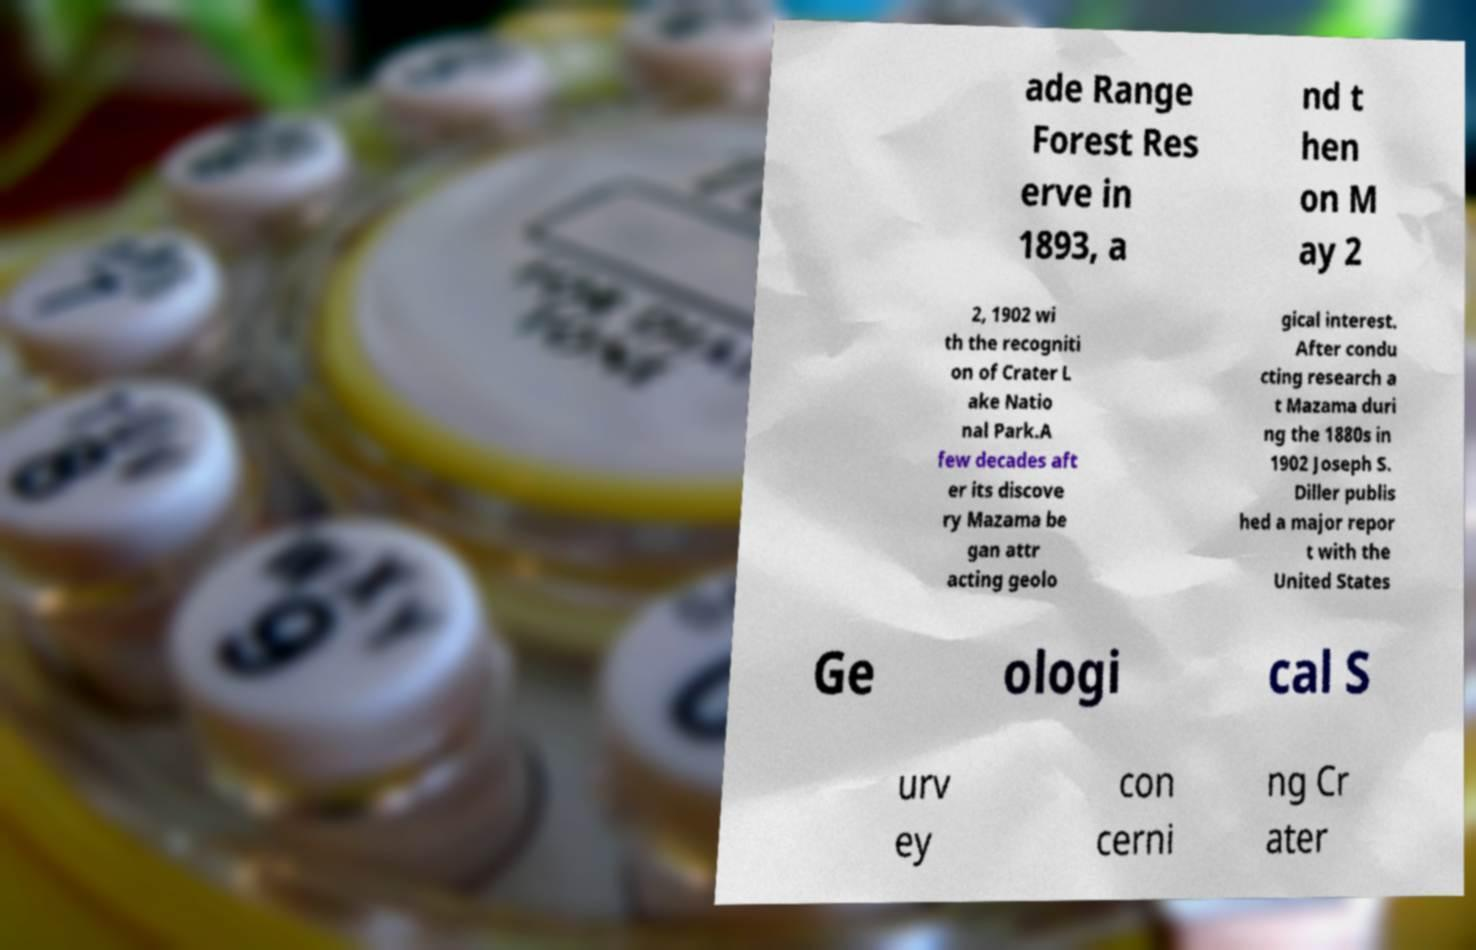Could you extract and type out the text from this image? ade Range Forest Res erve in 1893, a nd t hen on M ay 2 2, 1902 wi th the recogniti on of Crater L ake Natio nal Park.A few decades aft er its discove ry Mazama be gan attr acting geolo gical interest. After condu cting research a t Mazama duri ng the 1880s in 1902 Joseph S. Diller publis hed a major repor t with the United States Ge ologi cal S urv ey con cerni ng Cr ater 